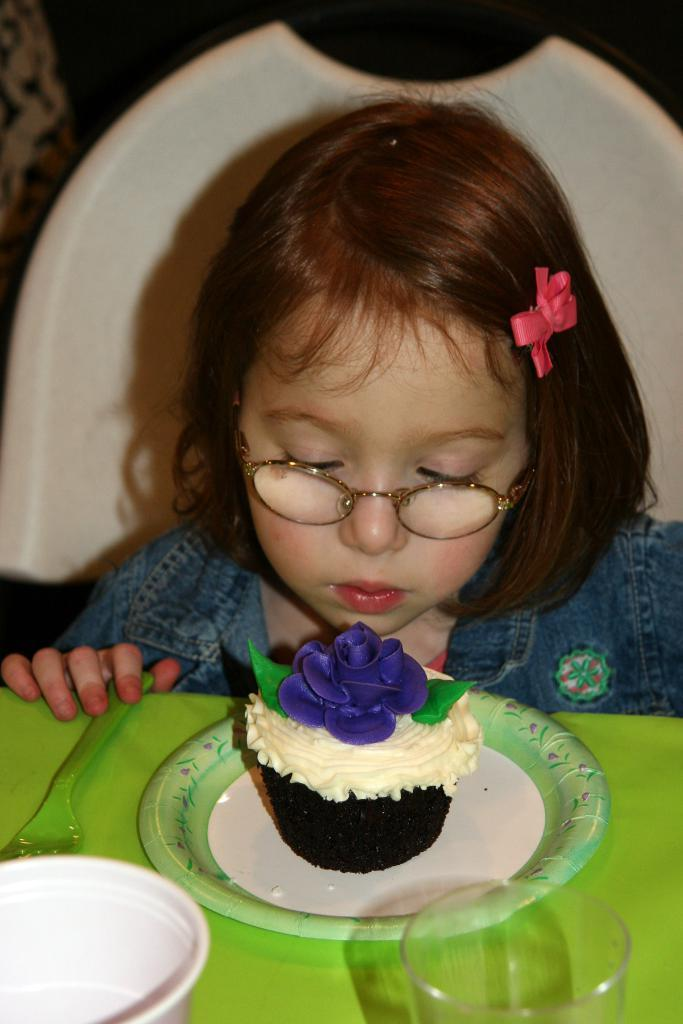What is the girl doing in the image? The girl is sitting on a chair in the image. Where is the girl positioned in relation to the table? The girl is in front of a table in the image. What items can be seen on the table? There is a plate, a glass, and a cup on the table in the image. What is on the plate? There is a cupcake in the plate in the image. What song is the girl singing in the image? There is no indication in the image that the girl is singing a song. 